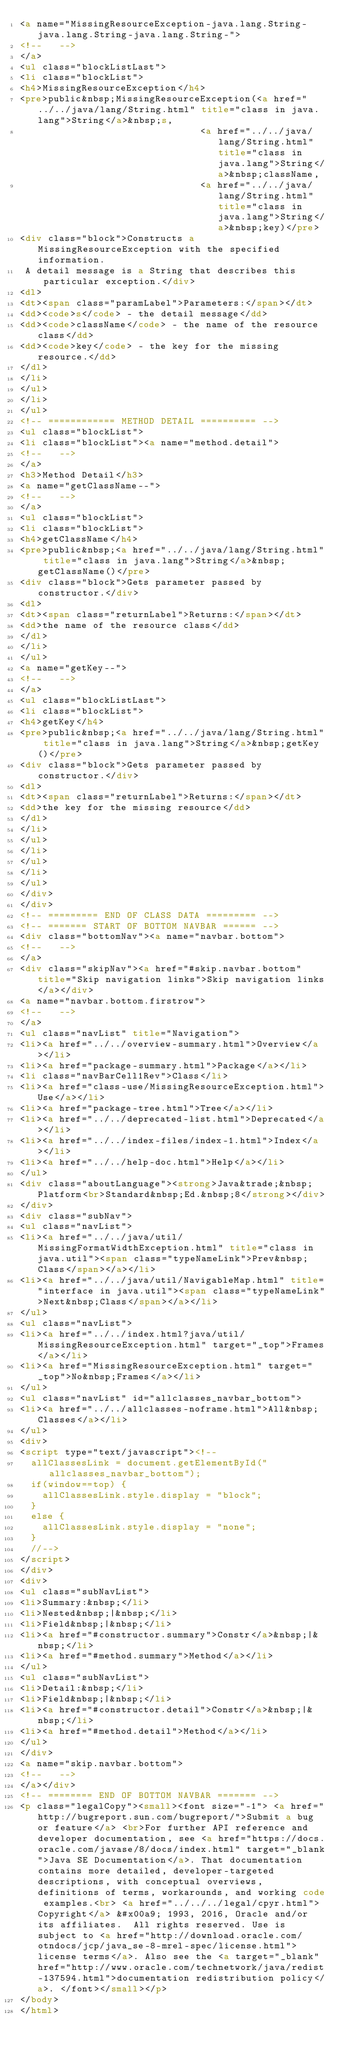Convert code to text. <code><loc_0><loc_0><loc_500><loc_500><_HTML_><a name="MissingResourceException-java.lang.String-java.lang.String-java.lang.String-">
<!--   -->
</a>
<ul class="blockListLast">
<li class="blockList">
<h4>MissingResourceException</h4>
<pre>public&nbsp;MissingResourceException(<a href="../../java/lang/String.html" title="class in java.lang">String</a>&nbsp;s,
                                <a href="../../java/lang/String.html" title="class in java.lang">String</a>&nbsp;className,
                                <a href="../../java/lang/String.html" title="class in java.lang">String</a>&nbsp;key)</pre>
<div class="block">Constructs a MissingResourceException with the specified information.
 A detail message is a String that describes this particular exception.</div>
<dl>
<dt><span class="paramLabel">Parameters:</span></dt>
<dd><code>s</code> - the detail message</dd>
<dd><code>className</code> - the name of the resource class</dd>
<dd><code>key</code> - the key for the missing resource.</dd>
</dl>
</li>
</ul>
</li>
</ul>
<!-- ============ METHOD DETAIL ========== -->
<ul class="blockList">
<li class="blockList"><a name="method.detail">
<!--   -->
</a>
<h3>Method Detail</h3>
<a name="getClassName--">
<!--   -->
</a>
<ul class="blockList">
<li class="blockList">
<h4>getClassName</h4>
<pre>public&nbsp;<a href="../../java/lang/String.html" title="class in java.lang">String</a>&nbsp;getClassName()</pre>
<div class="block">Gets parameter passed by constructor.</div>
<dl>
<dt><span class="returnLabel">Returns:</span></dt>
<dd>the name of the resource class</dd>
</dl>
</li>
</ul>
<a name="getKey--">
<!--   -->
</a>
<ul class="blockListLast">
<li class="blockList">
<h4>getKey</h4>
<pre>public&nbsp;<a href="../../java/lang/String.html" title="class in java.lang">String</a>&nbsp;getKey()</pre>
<div class="block">Gets parameter passed by constructor.</div>
<dl>
<dt><span class="returnLabel">Returns:</span></dt>
<dd>the key for the missing resource</dd>
</dl>
</li>
</ul>
</li>
</ul>
</li>
</ul>
</div>
</div>
<!-- ========= END OF CLASS DATA ========= -->
<!-- ======= START OF BOTTOM NAVBAR ====== -->
<div class="bottomNav"><a name="navbar.bottom">
<!--   -->
</a>
<div class="skipNav"><a href="#skip.navbar.bottom" title="Skip navigation links">Skip navigation links</a></div>
<a name="navbar.bottom.firstrow">
<!--   -->
</a>
<ul class="navList" title="Navigation">
<li><a href="../../overview-summary.html">Overview</a></li>
<li><a href="package-summary.html">Package</a></li>
<li class="navBarCell1Rev">Class</li>
<li><a href="class-use/MissingResourceException.html">Use</a></li>
<li><a href="package-tree.html">Tree</a></li>
<li><a href="../../deprecated-list.html">Deprecated</a></li>
<li><a href="../../index-files/index-1.html">Index</a></li>
<li><a href="../../help-doc.html">Help</a></li>
</ul>
<div class="aboutLanguage"><strong>Java&trade;&nbsp;Platform<br>Standard&nbsp;Ed.&nbsp;8</strong></div>
</div>
<div class="subNav">
<ul class="navList">
<li><a href="../../java/util/MissingFormatWidthException.html" title="class in java.util"><span class="typeNameLink">Prev&nbsp;Class</span></a></li>
<li><a href="../../java/util/NavigableMap.html" title="interface in java.util"><span class="typeNameLink">Next&nbsp;Class</span></a></li>
</ul>
<ul class="navList">
<li><a href="../../index.html?java/util/MissingResourceException.html" target="_top">Frames</a></li>
<li><a href="MissingResourceException.html" target="_top">No&nbsp;Frames</a></li>
</ul>
<ul class="navList" id="allclasses_navbar_bottom">
<li><a href="../../allclasses-noframe.html">All&nbsp;Classes</a></li>
</ul>
<div>
<script type="text/javascript"><!--
  allClassesLink = document.getElementById("allclasses_navbar_bottom");
  if(window==top) {
    allClassesLink.style.display = "block";
  }
  else {
    allClassesLink.style.display = "none";
  }
  //-->
</script>
</div>
<div>
<ul class="subNavList">
<li>Summary:&nbsp;</li>
<li>Nested&nbsp;|&nbsp;</li>
<li>Field&nbsp;|&nbsp;</li>
<li><a href="#constructor.summary">Constr</a>&nbsp;|&nbsp;</li>
<li><a href="#method.summary">Method</a></li>
</ul>
<ul class="subNavList">
<li>Detail:&nbsp;</li>
<li>Field&nbsp;|&nbsp;</li>
<li><a href="#constructor.detail">Constr</a>&nbsp;|&nbsp;</li>
<li><a href="#method.detail">Method</a></li>
</ul>
</div>
<a name="skip.navbar.bottom">
<!--   -->
</a></div>
<!-- ======== END OF BOTTOM NAVBAR ======= -->
<p class="legalCopy"><small><font size="-1"> <a href="http://bugreport.sun.com/bugreport/">Submit a bug or feature</a> <br>For further API reference and developer documentation, see <a href="https://docs.oracle.com/javase/8/docs/index.html" target="_blank">Java SE Documentation</a>. That documentation contains more detailed, developer-targeted descriptions, with conceptual overviews, definitions of terms, workarounds, and working code examples.<br> <a href="../../../legal/cpyr.html">Copyright</a> &#x00a9; 1993, 2016, Oracle and/or its affiliates.  All rights reserved. Use is subject to <a href="http://download.oracle.com/otndocs/jcp/java_se-8-mrel-spec/license.html">license terms</a>. Also see the <a target="_blank" href="http://www.oracle.com/technetwork/java/redist-137594.html">documentation redistribution policy</a>. </font></small></p>
</body>
</html>
</code> 